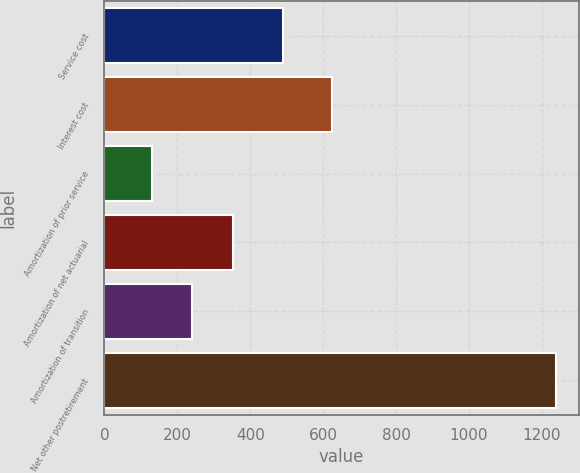Convert chart. <chart><loc_0><loc_0><loc_500><loc_500><bar_chart><fcel>Service cost<fcel>Interest cost<fcel>Amortization of prior service<fcel>Amortization of net actuarial<fcel>Amortization of transition<fcel>Net other postretirement<nl><fcel>490<fcel>624<fcel>130<fcel>351.8<fcel>240.9<fcel>1239<nl></chart> 